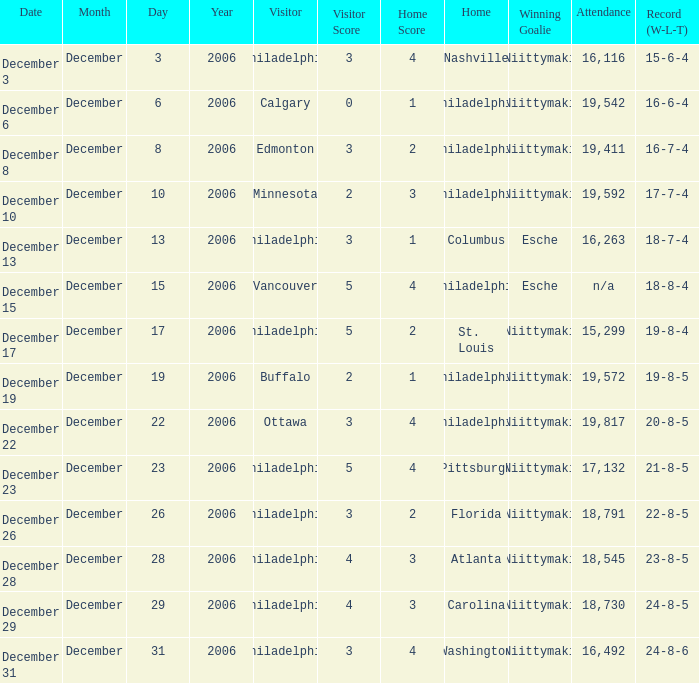What was the score when the attendance was 18,545? 4 – 3. 